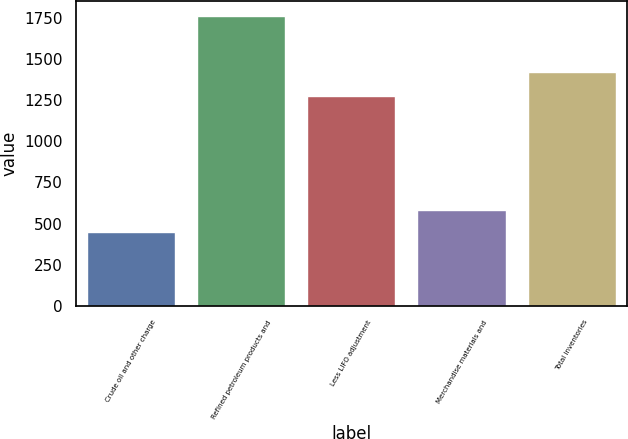Convert chart. <chart><loc_0><loc_0><loc_500><loc_500><bar_chart><fcel>Crude oil and other charge<fcel>Refined petroleum products and<fcel>Less LIFO adjustment<fcel>Merchandise materials and<fcel>Total inventories<nl><fcel>451<fcel>1762<fcel>1276<fcel>582.1<fcel>1423<nl></chart> 